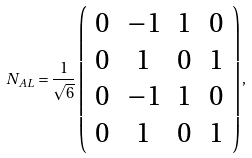Convert formula to latex. <formula><loc_0><loc_0><loc_500><loc_500>N _ { A L } = \frac { 1 } { \sqrt { 6 } } \left ( \begin{array} { c c c c } 0 & - 1 & 1 & 0 \\ 0 & 1 & 0 & 1 \\ 0 & - 1 & 1 & 0 \\ 0 & 1 & 0 & 1 \end{array} \right ) ,</formula> 